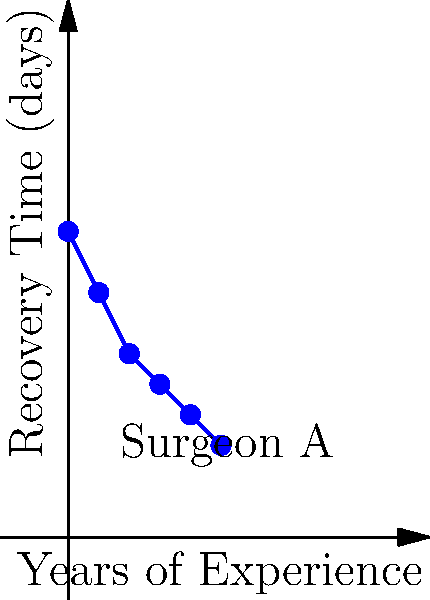Based on the graph showing the relationship between a surgeon's years of experience and patient recovery time, what type of regression model would be most appropriate to predict post-surgery recovery time, and what would be the estimated recovery time for a patient operated on by a surgeon with 3.5 years of experience? To answer this question, we need to follow these steps:

1. Analyze the relationship in the graph:
   The graph shows a non-linear relationship between years of experience and recovery time. As experience increases, recovery time decreases, but at a decreasing rate.

2. Choose the appropriate regression model:
   Given the non-linear relationship, a logarithmic regression model would be most appropriate. The curve appears to follow a logarithmic pattern, where the rate of decrease in recovery time slows down as experience increases.

3. Estimate the equation of the logarithmic regression:
   The general form of a logarithmic regression is $y = a \ln(x) + b$
   Using the data points, we can estimate the equation to be:
   $y \approx -3.5 \ln(x) + 10$

4. Calculate the estimated recovery time for 3.5 years of experience:
   Plugging in $x = 3.5$ into our estimated equation:
   $y = -3.5 \ln(3.5) + 10$
   $y \approx -3.5 * 1.25 + 10$
   $y \approx 5.625$

5. Round the result:
   Since recovery time is typically measured in whole days, we round 5.625 to 6 days.
Answer: Logarithmic regression; 6 days 